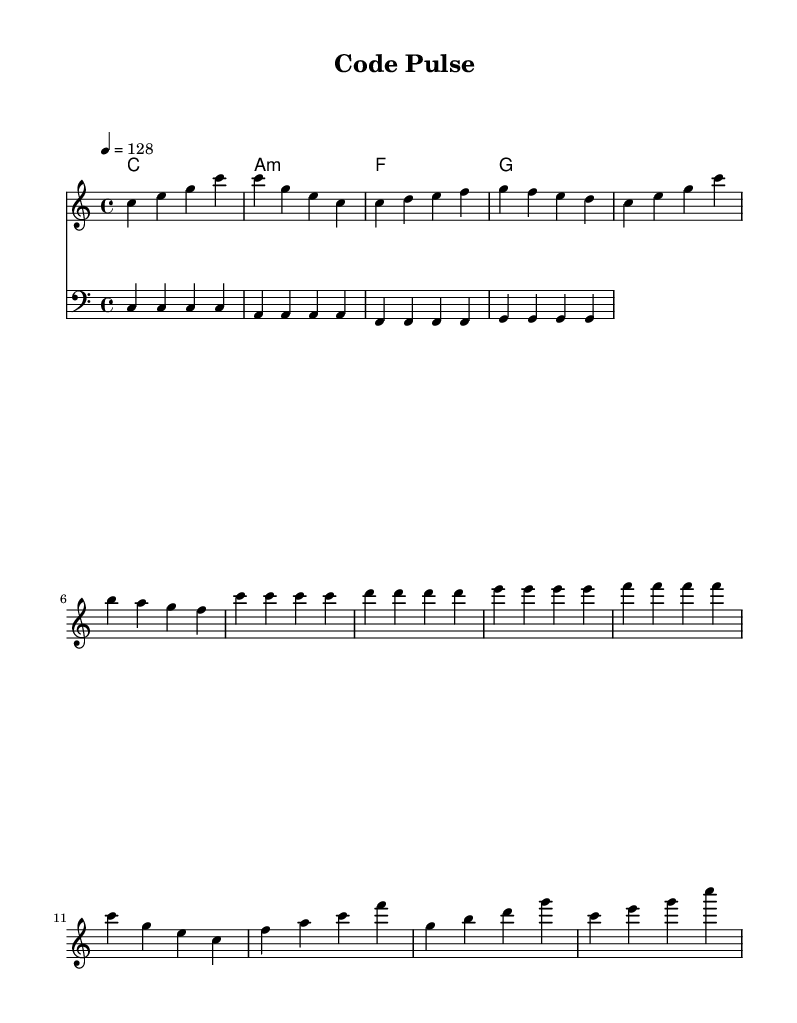What is the key signature of this music? The key signature indicated at the beginning of the sheet music is C major, which has no sharps or flats.
Answer: C major What is the time signature of this music? The time signature is found in the upper left corner of the sheet music and is written as 4/4, indicating four beats per measure.
Answer: 4/4 What is the tempo of this music? The tempo is indicated by the tempo marking "4 = 128," meaning there are 128 beats per minute.
Answer: 128 How many measures are in the melody section? By counting the groups of notes separated by vertical lines, the melody section contains 16 measures.
Answer: 16 Which chord is played during the drop section? The drop section features the chords corresponding to the notes in the melody, with the last chord being C major, as indicated at the end of the bar.
Answer: C What is the general structure of the music? The music is structured into four distinct sections: Intro, Verse, Build-up, and Drop, which are differentiated by their respective groupings of measures.
Answer: Intro, Verse, Build-up, Drop What musical style does this piece represent? The piece is categorized as Dance music due to its upbeat rhythm, electronic elements, and thematic focus on energetic and rhythmic qualities often found in electronic dance music.
Answer: Dance 